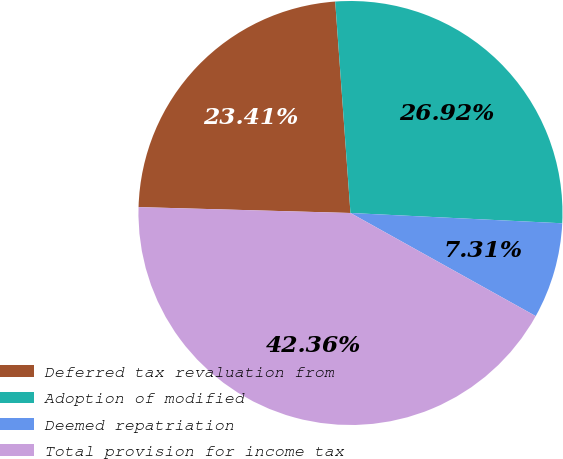Convert chart. <chart><loc_0><loc_0><loc_500><loc_500><pie_chart><fcel>Deferred tax revaluation from<fcel>Adoption of modified<fcel>Deemed repatriation<fcel>Total provision for income tax<nl><fcel>23.41%<fcel>26.92%<fcel>7.31%<fcel>42.36%<nl></chart> 